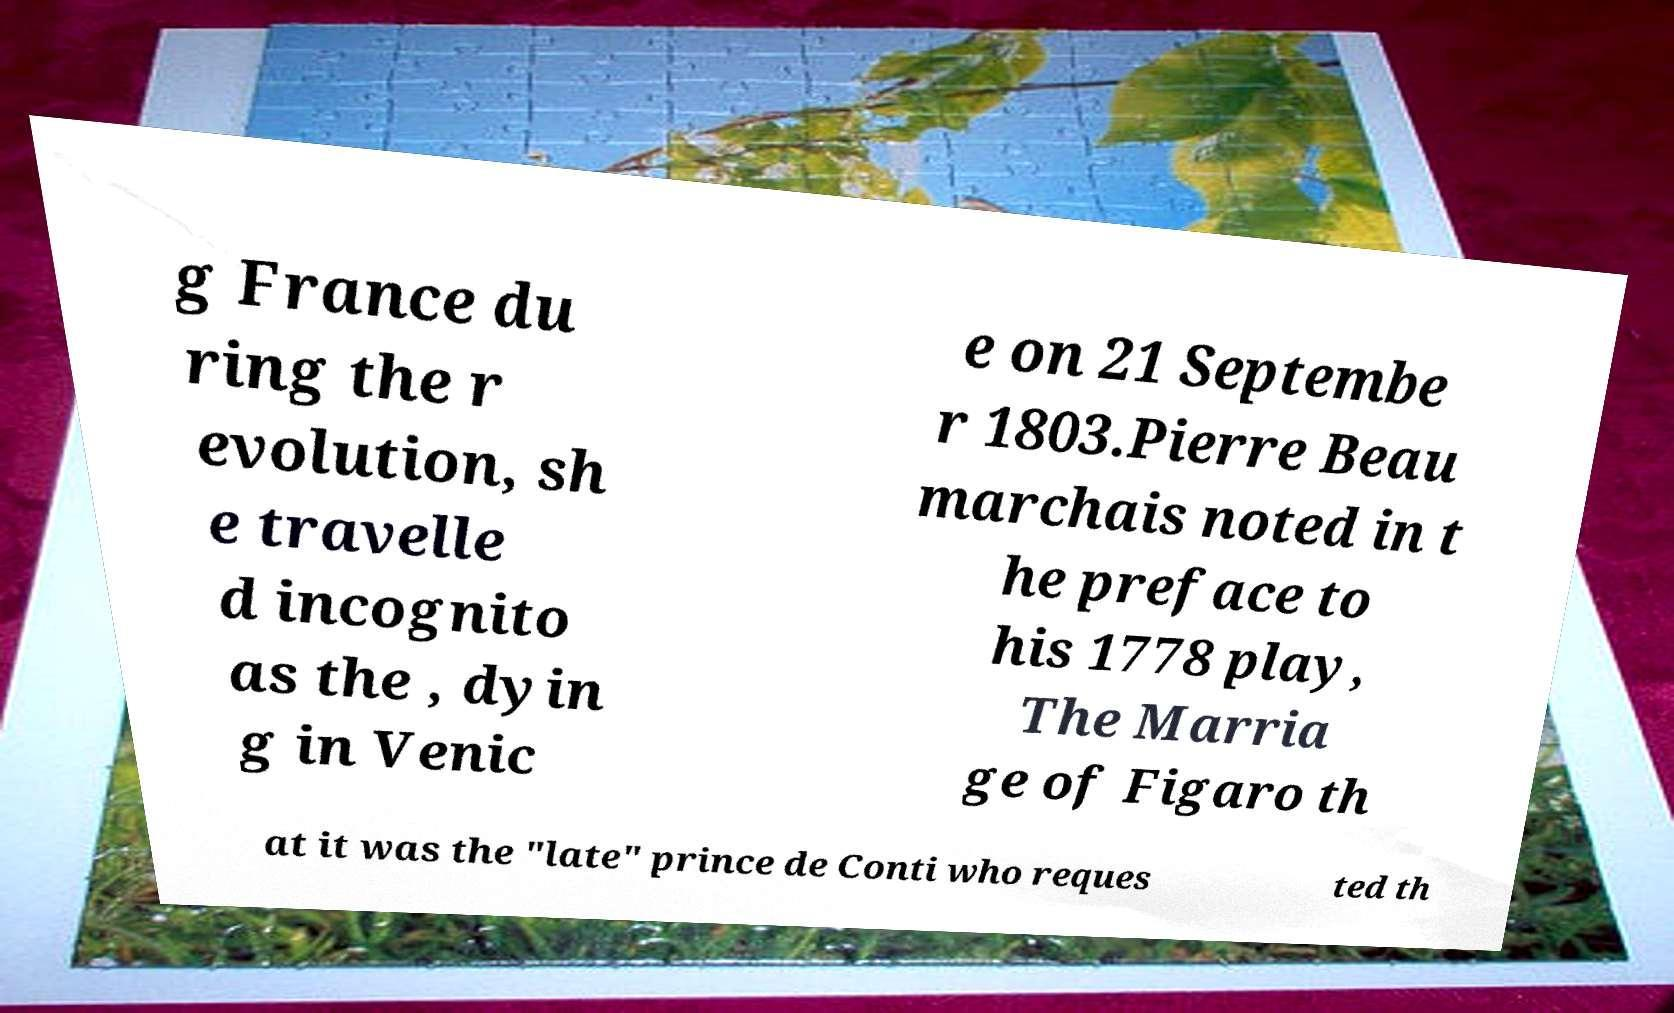Could you extract and type out the text from this image? g France du ring the r evolution, sh e travelle d incognito as the , dyin g in Venic e on 21 Septembe r 1803.Pierre Beau marchais noted in t he preface to his 1778 play, The Marria ge of Figaro th at it was the "late" prince de Conti who reques ted th 